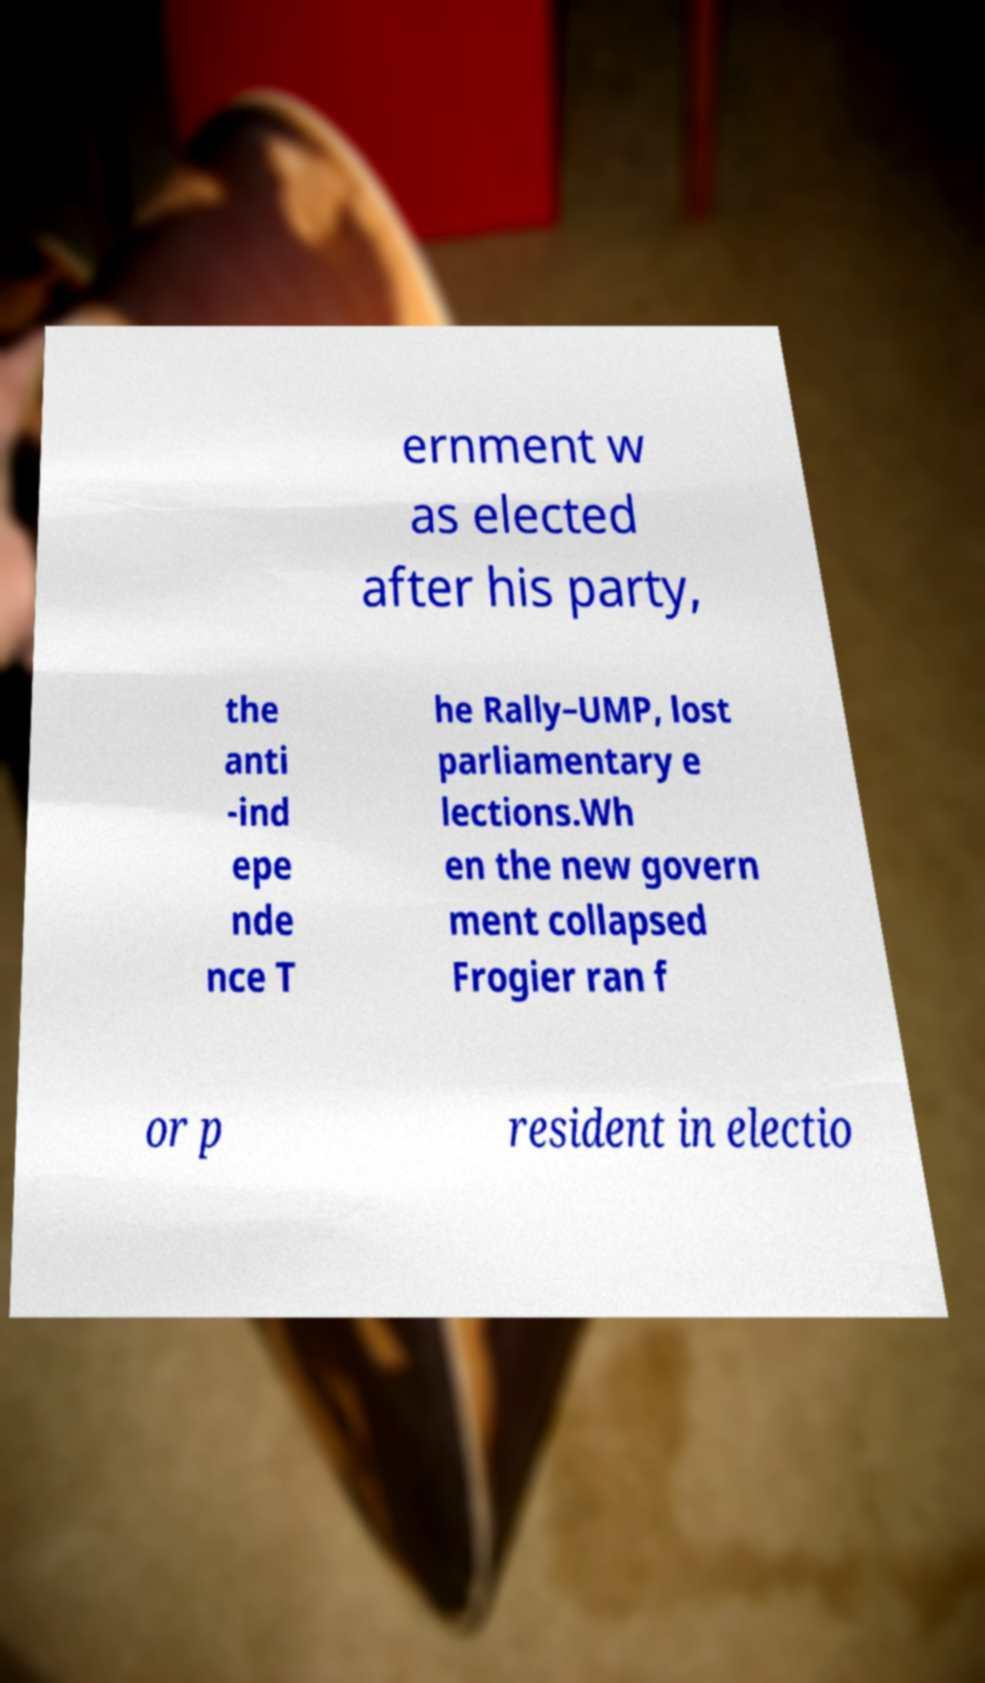Could you extract and type out the text from this image? ernment w as elected after his party, the anti -ind epe nde nce T he Rally–UMP, lost parliamentary e lections.Wh en the new govern ment collapsed Frogier ran f or p resident in electio 